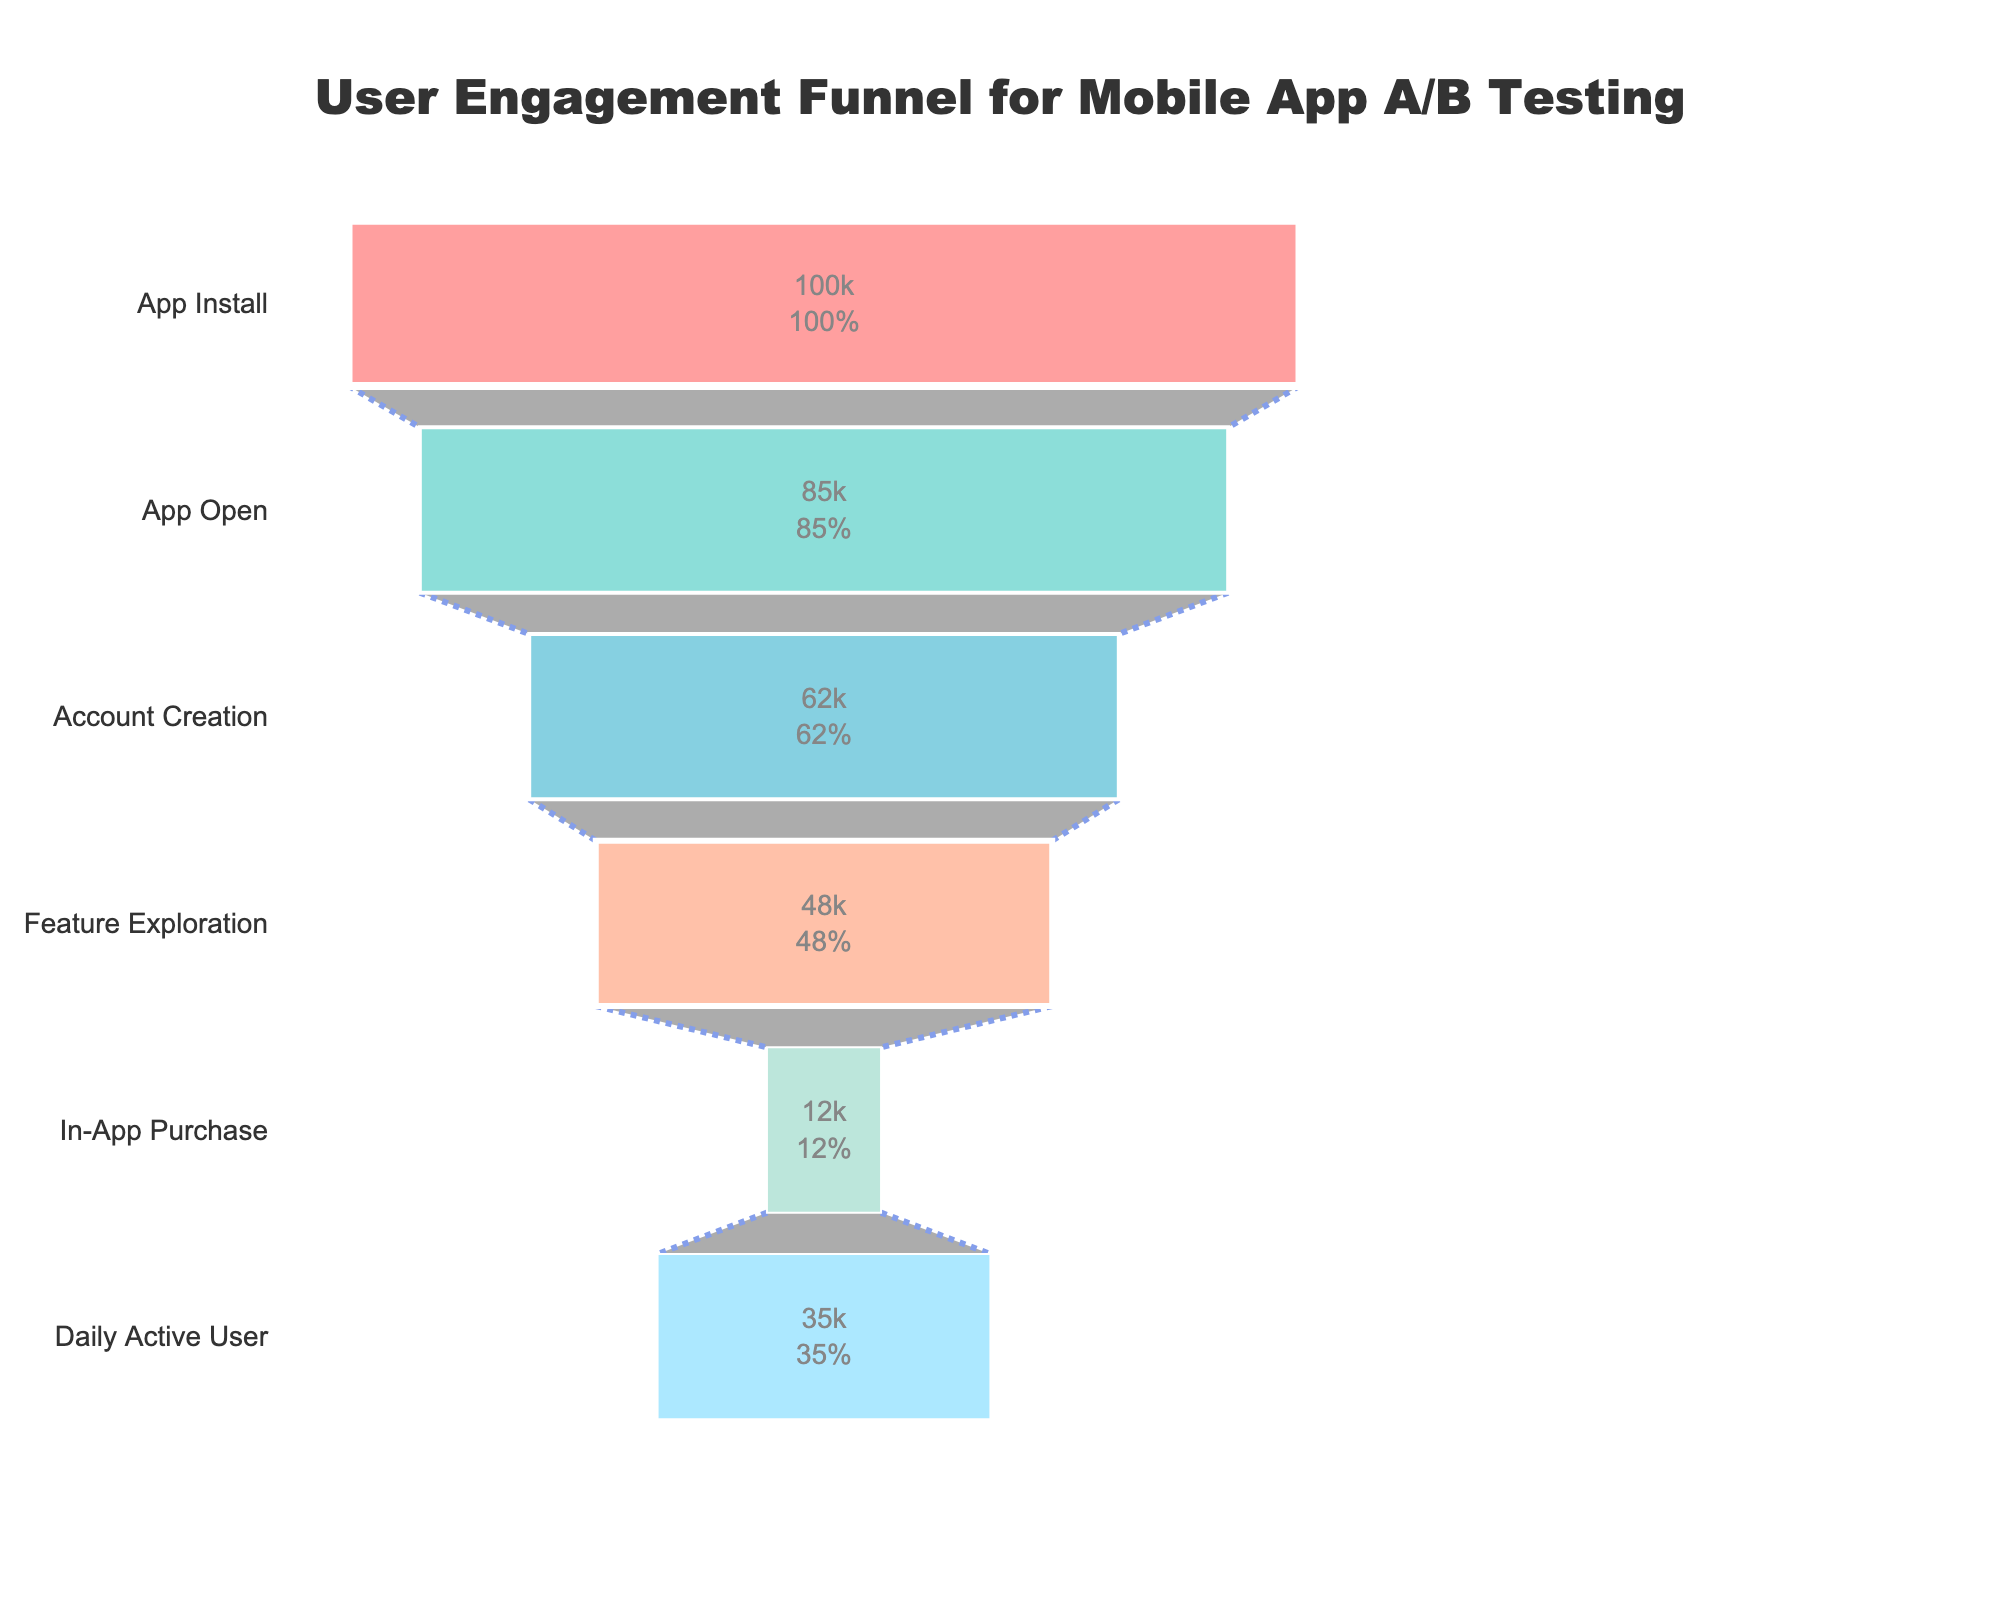What is the title of the funnel chart? The title is usually displayed at the top of the chart. In this case, it reads "User Engagement Funnel for Mobile App A/B Testing".
Answer: User Engagement Funnel for Mobile App A/B Testing How many stages are there in the funnel chart? By counting the number of different stages on the y-axis, we can see six stages in the funnel chart.
Answer: Six How many users are there at the Account Creation stage? The number of users at the Account Creation stage is displayed next to the bar for that stage on the chart.
Answer: 62,000 What's the difference in the number of users between the App Install and App Open stages? To find the difference, subtract the number of users at the App Open stage from those at the App Install stage: 100,000 - 85,000 = 15,000.
Answer: 15,000 Which stage has the fewest users? We can determine this by identifying the stage with the shortest bar on the x-axis. In this case, it is the In-App Purchase stage.
Answer: In-App Purchase What percentage of users who installed the app become Daily Active Users (DAUs)? To find this percentage, divide the number of Daily Active Users by the number of App Installs and multiply by 100: (35,000 / 100,000) * 100 = 35%.
Answer: 35% How many more users explore features compared to making in-app purchases? Subtract the number of users at the In-App Purchase stage from those at the Feature Exploration stage: 48,000 - 12,000 = 36,000.
Answer: 36,000 Which transition saw the biggest drop in users in absolute numbers? By checking the differences between consecutive stages, the largest drop is from Feature Exploration to In-App Purchase: 48,000 - 12,000 = 36,000.
Answer: Feature Exploration to In-App Purchase If an improvement strategy is focused on reducing the drop-off, which stage should be targeted first? We should target the stage with the biggest drop-off. From the data, the largest drop-off in users occurs between Feature Exploration and In-App Purchase.
Answer: Feature Exploration to In-App Purchase What is the conversion rate from App Open to Account Creation? To find the conversion rate, divide the number of users at the Account Creation stage by the number at the App Open stage and multiply by 100: (62,000 / 85,000) * 100 ≈ 72.94%.
Answer: Approximately 72.94% 